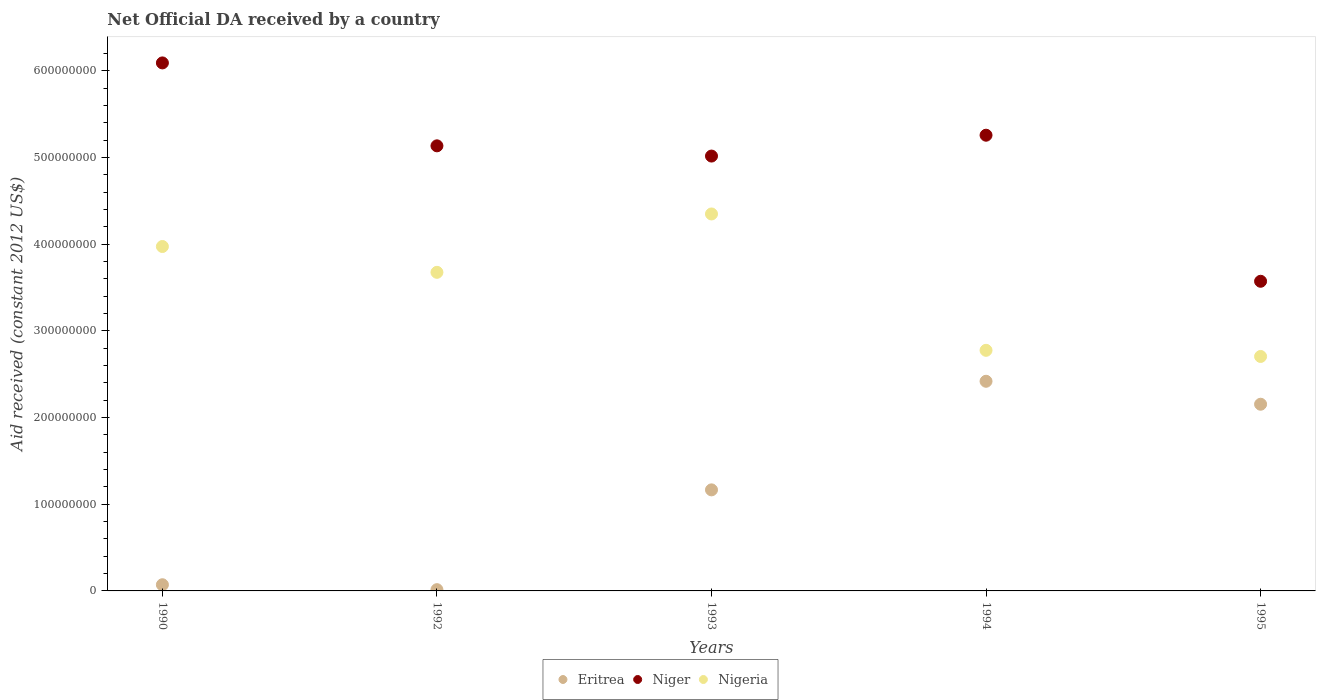Is the number of dotlines equal to the number of legend labels?
Give a very brief answer. Yes. What is the net official development assistance aid received in Eritrea in 1994?
Provide a short and direct response. 2.42e+08. Across all years, what is the maximum net official development assistance aid received in Eritrea?
Provide a short and direct response. 2.42e+08. Across all years, what is the minimum net official development assistance aid received in Niger?
Give a very brief answer. 3.57e+08. In which year was the net official development assistance aid received in Nigeria minimum?
Offer a terse response. 1995. What is the total net official development assistance aid received in Eritrea in the graph?
Your answer should be compact. 5.82e+08. What is the difference between the net official development assistance aid received in Nigeria in 1992 and that in 1993?
Offer a very short reply. -6.73e+07. What is the difference between the net official development assistance aid received in Niger in 1994 and the net official development assistance aid received in Nigeria in 1992?
Ensure brevity in your answer.  1.58e+08. What is the average net official development assistance aid received in Nigeria per year?
Keep it short and to the point. 3.50e+08. In the year 1994, what is the difference between the net official development assistance aid received in Eritrea and net official development assistance aid received in Nigeria?
Your answer should be compact. -3.57e+07. What is the ratio of the net official development assistance aid received in Eritrea in 1993 to that in 1994?
Keep it short and to the point. 0.48. Is the net official development assistance aid received in Nigeria in 1992 less than that in 1994?
Provide a succinct answer. No. What is the difference between the highest and the second highest net official development assistance aid received in Niger?
Ensure brevity in your answer.  8.34e+07. What is the difference between the highest and the lowest net official development assistance aid received in Niger?
Your response must be concise. 2.52e+08. Is the sum of the net official development assistance aid received in Eritrea in 1993 and 1994 greater than the maximum net official development assistance aid received in Niger across all years?
Make the answer very short. No. Is it the case that in every year, the sum of the net official development assistance aid received in Eritrea and net official development assistance aid received in Nigeria  is greater than the net official development assistance aid received in Niger?
Provide a succinct answer. No. How many years are there in the graph?
Offer a very short reply. 5. What is the difference between two consecutive major ticks on the Y-axis?
Provide a succinct answer. 1.00e+08. Does the graph contain any zero values?
Make the answer very short. No. Does the graph contain grids?
Your answer should be compact. No. Where does the legend appear in the graph?
Your answer should be very brief. Bottom center. How are the legend labels stacked?
Provide a short and direct response. Horizontal. What is the title of the graph?
Offer a terse response. Net Official DA received by a country. What is the label or title of the Y-axis?
Your answer should be very brief. Aid received (constant 2012 US$). What is the Aid received (constant 2012 US$) of Eritrea in 1990?
Offer a terse response. 7.13e+06. What is the Aid received (constant 2012 US$) in Niger in 1990?
Provide a short and direct response. 6.09e+08. What is the Aid received (constant 2012 US$) in Nigeria in 1990?
Provide a short and direct response. 3.97e+08. What is the Aid received (constant 2012 US$) of Eritrea in 1992?
Offer a terse response. 1.45e+06. What is the Aid received (constant 2012 US$) of Niger in 1992?
Your answer should be very brief. 5.13e+08. What is the Aid received (constant 2012 US$) in Nigeria in 1992?
Offer a terse response. 3.68e+08. What is the Aid received (constant 2012 US$) of Eritrea in 1993?
Offer a terse response. 1.17e+08. What is the Aid received (constant 2012 US$) in Niger in 1993?
Your answer should be very brief. 5.02e+08. What is the Aid received (constant 2012 US$) of Nigeria in 1993?
Provide a short and direct response. 4.35e+08. What is the Aid received (constant 2012 US$) in Eritrea in 1994?
Ensure brevity in your answer.  2.42e+08. What is the Aid received (constant 2012 US$) of Niger in 1994?
Provide a short and direct response. 5.26e+08. What is the Aid received (constant 2012 US$) in Nigeria in 1994?
Give a very brief answer. 2.78e+08. What is the Aid received (constant 2012 US$) in Eritrea in 1995?
Make the answer very short. 2.15e+08. What is the Aid received (constant 2012 US$) in Niger in 1995?
Your response must be concise. 3.57e+08. What is the Aid received (constant 2012 US$) of Nigeria in 1995?
Your answer should be very brief. 2.70e+08. Across all years, what is the maximum Aid received (constant 2012 US$) in Eritrea?
Ensure brevity in your answer.  2.42e+08. Across all years, what is the maximum Aid received (constant 2012 US$) in Niger?
Offer a very short reply. 6.09e+08. Across all years, what is the maximum Aid received (constant 2012 US$) of Nigeria?
Offer a very short reply. 4.35e+08. Across all years, what is the minimum Aid received (constant 2012 US$) of Eritrea?
Your answer should be very brief. 1.45e+06. Across all years, what is the minimum Aid received (constant 2012 US$) of Niger?
Provide a short and direct response. 3.57e+08. Across all years, what is the minimum Aid received (constant 2012 US$) of Nigeria?
Offer a terse response. 2.70e+08. What is the total Aid received (constant 2012 US$) in Eritrea in the graph?
Give a very brief answer. 5.82e+08. What is the total Aid received (constant 2012 US$) in Niger in the graph?
Make the answer very short. 2.51e+09. What is the total Aid received (constant 2012 US$) in Nigeria in the graph?
Your answer should be very brief. 1.75e+09. What is the difference between the Aid received (constant 2012 US$) in Eritrea in 1990 and that in 1992?
Your answer should be compact. 5.68e+06. What is the difference between the Aid received (constant 2012 US$) of Niger in 1990 and that in 1992?
Your answer should be compact. 9.57e+07. What is the difference between the Aid received (constant 2012 US$) in Nigeria in 1990 and that in 1992?
Give a very brief answer. 2.98e+07. What is the difference between the Aid received (constant 2012 US$) of Eritrea in 1990 and that in 1993?
Your answer should be compact. -1.09e+08. What is the difference between the Aid received (constant 2012 US$) in Niger in 1990 and that in 1993?
Provide a succinct answer. 1.07e+08. What is the difference between the Aid received (constant 2012 US$) in Nigeria in 1990 and that in 1993?
Keep it short and to the point. -3.75e+07. What is the difference between the Aid received (constant 2012 US$) of Eritrea in 1990 and that in 1994?
Keep it short and to the point. -2.35e+08. What is the difference between the Aid received (constant 2012 US$) in Niger in 1990 and that in 1994?
Make the answer very short. 8.34e+07. What is the difference between the Aid received (constant 2012 US$) of Nigeria in 1990 and that in 1994?
Your answer should be compact. 1.20e+08. What is the difference between the Aid received (constant 2012 US$) in Eritrea in 1990 and that in 1995?
Your answer should be compact. -2.08e+08. What is the difference between the Aid received (constant 2012 US$) of Niger in 1990 and that in 1995?
Offer a terse response. 2.52e+08. What is the difference between the Aid received (constant 2012 US$) in Nigeria in 1990 and that in 1995?
Ensure brevity in your answer.  1.27e+08. What is the difference between the Aid received (constant 2012 US$) of Eritrea in 1992 and that in 1993?
Your answer should be compact. -1.15e+08. What is the difference between the Aid received (constant 2012 US$) of Niger in 1992 and that in 1993?
Ensure brevity in your answer.  1.18e+07. What is the difference between the Aid received (constant 2012 US$) in Nigeria in 1992 and that in 1993?
Your answer should be very brief. -6.73e+07. What is the difference between the Aid received (constant 2012 US$) in Eritrea in 1992 and that in 1994?
Provide a short and direct response. -2.40e+08. What is the difference between the Aid received (constant 2012 US$) of Niger in 1992 and that in 1994?
Provide a short and direct response. -1.23e+07. What is the difference between the Aid received (constant 2012 US$) in Nigeria in 1992 and that in 1994?
Your answer should be compact. 9.00e+07. What is the difference between the Aid received (constant 2012 US$) in Eritrea in 1992 and that in 1995?
Offer a very short reply. -2.14e+08. What is the difference between the Aid received (constant 2012 US$) of Niger in 1992 and that in 1995?
Make the answer very short. 1.56e+08. What is the difference between the Aid received (constant 2012 US$) in Nigeria in 1992 and that in 1995?
Your answer should be very brief. 9.71e+07. What is the difference between the Aid received (constant 2012 US$) in Eritrea in 1993 and that in 1994?
Ensure brevity in your answer.  -1.25e+08. What is the difference between the Aid received (constant 2012 US$) in Niger in 1993 and that in 1994?
Your response must be concise. -2.41e+07. What is the difference between the Aid received (constant 2012 US$) of Nigeria in 1993 and that in 1994?
Provide a succinct answer. 1.57e+08. What is the difference between the Aid received (constant 2012 US$) of Eritrea in 1993 and that in 1995?
Provide a succinct answer. -9.88e+07. What is the difference between the Aid received (constant 2012 US$) of Niger in 1993 and that in 1995?
Make the answer very short. 1.44e+08. What is the difference between the Aid received (constant 2012 US$) of Nigeria in 1993 and that in 1995?
Provide a short and direct response. 1.64e+08. What is the difference between the Aid received (constant 2012 US$) of Eritrea in 1994 and that in 1995?
Make the answer very short. 2.65e+07. What is the difference between the Aid received (constant 2012 US$) in Niger in 1994 and that in 1995?
Ensure brevity in your answer.  1.68e+08. What is the difference between the Aid received (constant 2012 US$) of Nigeria in 1994 and that in 1995?
Provide a short and direct response. 7.09e+06. What is the difference between the Aid received (constant 2012 US$) of Eritrea in 1990 and the Aid received (constant 2012 US$) of Niger in 1992?
Your answer should be compact. -5.06e+08. What is the difference between the Aid received (constant 2012 US$) in Eritrea in 1990 and the Aid received (constant 2012 US$) in Nigeria in 1992?
Provide a short and direct response. -3.60e+08. What is the difference between the Aid received (constant 2012 US$) in Niger in 1990 and the Aid received (constant 2012 US$) in Nigeria in 1992?
Provide a short and direct response. 2.42e+08. What is the difference between the Aid received (constant 2012 US$) of Eritrea in 1990 and the Aid received (constant 2012 US$) of Niger in 1993?
Make the answer very short. -4.95e+08. What is the difference between the Aid received (constant 2012 US$) in Eritrea in 1990 and the Aid received (constant 2012 US$) in Nigeria in 1993?
Keep it short and to the point. -4.28e+08. What is the difference between the Aid received (constant 2012 US$) in Niger in 1990 and the Aid received (constant 2012 US$) in Nigeria in 1993?
Keep it short and to the point. 1.74e+08. What is the difference between the Aid received (constant 2012 US$) of Eritrea in 1990 and the Aid received (constant 2012 US$) of Niger in 1994?
Ensure brevity in your answer.  -5.19e+08. What is the difference between the Aid received (constant 2012 US$) of Eritrea in 1990 and the Aid received (constant 2012 US$) of Nigeria in 1994?
Give a very brief answer. -2.70e+08. What is the difference between the Aid received (constant 2012 US$) in Niger in 1990 and the Aid received (constant 2012 US$) in Nigeria in 1994?
Provide a short and direct response. 3.32e+08. What is the difference between the Aid received (constant 2012 US$) in Eritrea in 1990 and the Aid received (constant 2012 US$) in Niger in 1995?
Your response must be concise. -3.50e+08. What is the difference between the Aid received (constant 2012 US$) in Eritrea in 1990 and the Aid received (constant 2012 US$) in Nigeria in 1995?
Your response must be concise. -2.63e+08. What is the difference between the Aid received (constant 2012 US$) in Niger in 1990 and the Aid received (constant 2012 US$) in Nigeria in 1995?
Offer a very short reply. 3.39e+08. What is the difference between the Aid received (constant 2012 US$) of Eritrea in 1992 and the Aid received (constant 2012 US$) of Niger in 1993?
Your response must be concise. -5.00e+08. What is the difference between the Aid received (constant 2012 US$) in Eritrea in 1992 and the Aid received (constant 2012 US$) in Nigeria in 1993?
Ensure brevity in your answer.  -4.33e+08. What is the difference between the Aid received (constant 2012 US$) of Niger in 1992 and the Aid received (constant 2012 US$) of Nigeria in 1993?
Give a very brief answer. 7.86e+07. What is the difference between the Aid received (constant 2012 US$) in Eritrea in 1992 and the Aid received (constant 2012 US$) in Niger in 1994?
Your answer should be compact. -5.24e+08. What is the difference between the Aid received (constant 2012 US$) of Eritrea in 1992 and the Aid received (constant 2012 US$) of Nigeria in 1994?
Your response must be concise. -2.76e+08. What is the difference between the Aid received (constant 2012 US$) in Niger in 1992 and the Aid received (constant 2012 US$) in Nigeria in 1994?
Give a very brief answer. 2.36e+08. What is the difference between the Aid received (constant 2012 US$) of Eritrea in 1992 and the Aid received (constant 2012 US$) of Niger in 1995?
Give a very brief answer. -3.56e+08. What is the difference between the Aid received (constant 2012 US$) in Eritrea in 1992 and the Aid received (constant 2012 US$) in Nigeria in 1995?
Offer a terse response. -2.69e+08. What is the difference between the Aid received (constant 2012 US$) of Niger in 1992 and the Aid received (constant 2012 US$) of Nigeria in 1995?
Make the answer very short. 2.43e+08. What is the difference between the Aid received (constant 2012 US$) of Eritrea in 1993 and the Aid received (constant 2012 US$) of Niger in 1994?
Provide a short and direct response. -4.09e+08. What is the difference between the Aid received (constant 2012 US$) in Eritrea in 1993 and the Aid received (constant 2012 US$) in Nigeria in 1994?
Provide a succinct answer. -1.61e+08. What is the difference between the Aid received (constant 2012 US$) of Niger in 1993 and the Aid received (constant 2012 US$) of Nigeria in 1994?
Your response must be concise. 2.24e+08. What is the difference between the Aid received (constant 2012 US$) of Eritrea in 1993 and the Aid received (constant 2012 US$) of Niger in 1995?
Give a very brief answer. -2.41e+08. What is the difference between the Aid received (constant 2012 US$) in Eritrea in 1993 and the Aid received (constant 2012 US$) in Nigeria in 1995?
Offer a very short reply. -1.54e+08. What is the difference between the Aid received (constant 2012 US$) in Niger in 1993 and the Aid received (constant 2012 US$) in Nigeria in 1995?
Your response must be concise. 2.31e+08. What is the difference between the Aid received (constant 2012 US$) of Eritrea in 1994 and the Aid received (constant 2012 US$) of Niger in 1995?
Your answer should be compact. -1.15e+08. What is the difference between the Aid received (constant 2012 US$) in Eritrea in 1994 and the Aid received (constant 2012 US$) in Nigeria in 1995?
Your answer should be very brief. -2.86e+07. What is the difference between the Aid received (constant 2012 US$) of Niger in 1994 and the Aid received (constant 2012 US$) of Nigeria in 1995?
Your response must be concise. 2.55e+08. What is the average Aid received (constant 2012 US$) in Eritrea per year?
Give a very brief answer. 1.16e+08. What is the average Aid received (constant 2012 US$) of Niger per year?
Give a very brief answer. 5.01e+08. What is the average Aid received (constant 2012 US$) of Nigeria per year?
Provide a short and direct response. 3.50e+08. In the year 1990, what is the difference between the Aid received (constant 2012 US$) of Eritrea and Aid received (constant 2012 US$) of Niger?
Your response must be concise. -6.02e+08. In the year 1990, what is the difference between the Aid received (constant 2012 US$) in Eritrea and Aid received (constant 2012 US$) in Nigeria?
Ensure brevity in your answer.  -3.90e+08. In the year 1990, what is the difference between the Aid received (constant 2012 US$) of Niger and Aid received (constant 2012 US$) of Nigeria?
Your answer should be compact. 2.12e+08. In the year 1992, what is the difference between the Aid received (constant 2012 US$) in Eritrea and Aid received (constant 2012 US$) in Niger?
Ensure brevity in your answer.  -5.12e+08. In the year 1992, what is the difference between the Aid received (constant 2012 US$) in Eritrea and Aid received (constant 2012 US$) in Nigeria?
Offer a terse response. -3.66e+08. In the year 1992, what is the difference between the Aid received (constant 2012 US$) in Niger and Aid received (constant 2012 US$) in Nigeria?
Provide a succinct answer. 1.46e+08. In the year 1993, what is the difference between the Aid received (constant 2012 US$) in Eritrea and Aid received (constant 2012 US$) in Niger?
Make the answer very short. -3.85e+08. In the year 1993, what is the difference between the Aid received (constant 2012 US$) in Eritrea and Aid received (constant 2012 US$) in Nigeria?
Keep it short and to the point. -3.18e+08. In the year 1993, what is the difference between the Aid received (constant 2012 US$) of Niger and Aid received (constant 2012 US$) of Nigeria?
Provide a short and direct response. 6.68e+07. In the year 1994, what is the difference between the Aid received (constant 2012 US$) of Eritrea and Aid received (constant 2012 US$) of Niger?
Make the answer very short. -2.84e+08. In the year 1994, what is the difference between the Aid received (constant 2012 US$) in Eritrea and Aid received (constant 2012 US$) in Nigeria?
Your answer should be compact. -3.57e+07. In the year 1994, what is the difference between the Aid received (constant 2012 US$) of Niger and Aid received (constant 2012 US$) of Nigeria?
Make the answer very short. 2.48e+08. In the year 1995, what is the difference between the Aid received (constant 2012 US$) of Eritrea and Aid received (constant 2012 US$) of Niger?
Provide a short and direct response. -1.42e+08. In the year 1995, what is the difference between the Aid received (constant 2012 US$) of Eritrea and Aid received (constant 2012 US$) of Nigeria?
Make the answer very short. -5.51e+07. In the year 1995, what is the difference between the Aid received (constant 2012 US$) of Niger and Aid received (constant 2012 US$) of Nigeria?
Provide a short and direct response. 8.67e+07. What is the ratio of the Aid received (constant 2012 US$) in Eritrea in 1990 to that in 1992?
Your answer should be very brief. 4.92. What is the ratio of the Aid received (constant 2012 US$) in Niger in 1990 to that in 1992?
Provide a short and direct response. 1.19. What is the ratio of the Aid received (constant 2012 US$) in Nigeria in 1990 to that in 1992?
Offer a terse response. 1.08. What is the ratio of the Aid received (constant 2012 US$) in Eritrea in 1990 to that in 1993?
Your answer should be very brief. 0.06. What is the ratio of the Aid received (constant 2012 US$) of Niger in 1990 to that in 1993?
Your answer should be compact. 1.21. What is the ratio of the Aid received (constant 2012 US$) of Nigeria in 1990 to that in 1993?
Your response must be concise. 0.91. What is the ratio of the Aid received (constant 2012 US$) in Eritrea in 1990 to that in 1994?
Provide a succinct answer. 0.03. What is the ratio of the Aid received (constant 2012 US$) in Niger in 1990 to that in 1994?
Ensure brevity in your answer.  1.16. What is the ratio of the Aid received (constant 2012 US$) in Nigeria in 1990 to that in 1994?
Your response must be concise. 1.43. What is the ratio of the Aid received (constant 2012 US$) in Eritrea in 1990 to that in 1995?
Keep it short and to the point. 0.03. What is the ratio of the Aid received (constant 2012 US$) of Niger in 1990 to that in 1995?
Provide a succinct answer. 1.71. What is the ratio of the Aid received (constant 2012 US$) of Nigeria in 1990 to that in 1995?
Make the answer very short. 1.47. What is the ratio of the Aid received (constant 2012 US$) in Eritrea in 1992 to that in 1993?
Keep it short and to the point. 0.01. What is the ratio of the Aid received (constant 2012 US$) of Niger in 1992 to that in 1993?
Offer a terse response. 1.02. What is the ratio of the Aid received (constant 2012 US$) of Nigeria in 1992 to that in 1993?
Provide a succinct answer. 0.85. What is the ratio of the Aid received (constant 2012 US$) in Eritrea in 1992 to that in 1994?
Give a very brief answer. 0.01. What is the ratio of the Aid received (constant 2012 US$) in Niger in 1992 to that in 1994?
Your answer should be very brief. 0.98. What is the ratio of the Aid received (constant 2012 US$) of Nigeria in 1992 to that in 1994?
Ensure brevity in your answer.  1.32. What is the ratio of the Aid received (constant 2012 US$) in Eritrea in 1992 to that in 1995?
Provide a succinct answer. 0.01. What is the ratio of the Aid received (constant 2012 US$) in Niger in 1992 to that in 1995?
Your answer should be compact. 1.44. What is the ratio of the Aid received (constant 2012 US$) of Nigeria in 1992 to that in 1995?
Keep it short and to the point. 1.36. What is the ratio of the Aid received (constant 2012 US$) in Eritrea in 1993 to that in 1994?
Your answer should be compact. 0.48. What is the ratio of the Aid received (constant 2012 US$) of Niger in 1993 to that in 1994?
Keep it short and to the point. 0.95. What is the ratio of the Aid received (constant 2012 US$) of Nigeria in 1993 to that in 1994?
Your answer should be compact. 1.57. What is the ratio of the Aid received (constant 2012 US$) in Eritrea in 1993 to that in 1995?
Keep it short and to the point. 0.54. What is the ratio of the Aid received (constant 2012 US$) of Niger in 1993 to that in 1995?
Keep it short and to the point. 1.4. What is the ratio of the Aid received (constant 2012 US$) in Nigeria in 1993 to that in 1995?
Offer a terse response. 1.61. What is the ratio of the Aid received (constant 2012 US$) in Eritrea in 1994 to that in 1995?
Your answer should be compact. 1.12. What is the ratio of the Aid received (constant 2012 US$) of Niger in 1994 to that in 1995?
Provide a succinct answer. 1.47. What is the ratio of the Aid received (constant 2012 US$) in Nigeria in 1994 to that in 1995?
Your answer should be very brief. 1.03. What is the difference between the highest and the second highest Aid received (constant 2012 US$) in Eritrea?
Your answer should be compact. 2.65e+07. What is the difference between the highest and the second highest Aid received (constant 2012 US$) of Niger?
Ensure brevity in your answer.  8.34e+07. What is the difference between the highest and the second highest Aid received (constant 2012 US$) of Nigeria?
Provide a short and direct response. 3.75e+07. What is the difference between the highest and the lowest Aid received (constant 2012 US$) in Eritrea?
Offer a terse response. 2.40e+08. What is the difference between the highest and the lowest Aid received (constant 2012 US$) of Niger?
Keep it short and to the point. 2.52e+08. What is the difference between the highest and the lowest Aid received (constant 2012 US$) in Nigeria?
Give a very brief answer. 1.64e+08. 